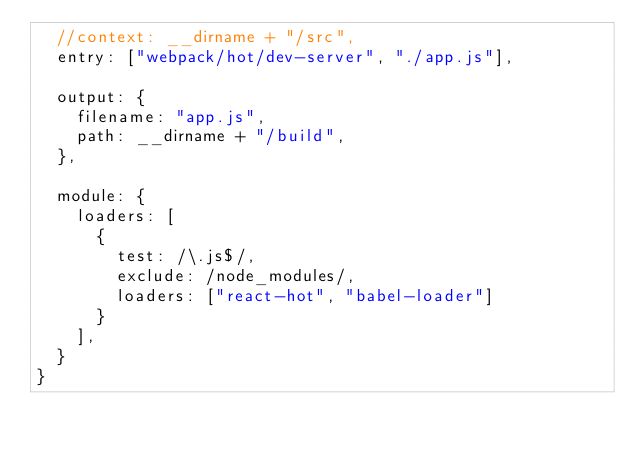<code> <loc_0><loc_0><loc_500><loc_500><_JavaScript_>  //context: __dirname + "/src",
  entry: ["webpack/hot/dev-server", "./app.js"],

  output: {
    filename: "app.js",
    path: __dirname + "/build",
  },

  module: {
    loaders: [
      {
        test: /\.js$/,
        exclude: /node_modules/,
        loaders: ["react-hot", "babel-loader"]
      }
    ],
  }
}</code> 